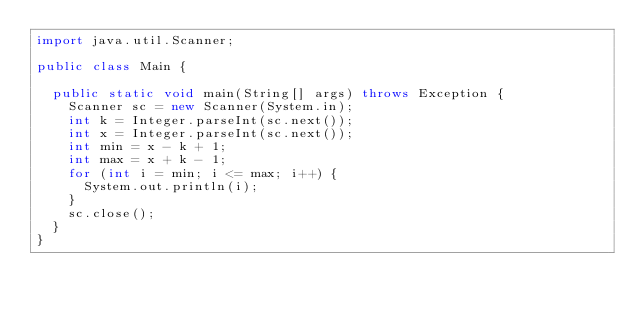Convert code to text. <code><loc_0><loc_0><loc_500><loc_500><_Java_>import java.util.Scanner;

public class Main {

	public static void main(String[] args) throws Exception {
		Scanner sc = new Scanner(System.in);
		int k = Integer.parseInt(sc.next());
		int x = Integer.parseInt(sc.next());
		int min = x - k + 1;
		int max = x + k - 1;
		for (int i = min; i <= max; i++) {
			System.out.println(i);
		}
		sc.close();
	}
}</code> 